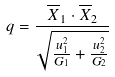<formula> <loc_0><loc_0><loc_500><loc_500>q = \frac { \overline { X } _ { 1 } \cdot \overline { X } _ { 2 } } { \sqrt { \frac { u _ { 1 } ^ { 2 } } { G _ { 1 } } + \frac { u _ { 2 } ^ { 2 } } { G _ { 2 } } } }</formula> 